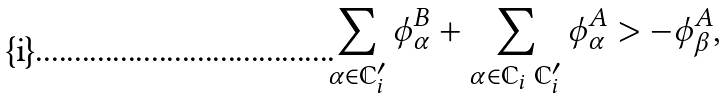Convert formula to latex. <formula><loc_0><loc_0><loc_500><loc_500>\sum _ { \alpha \in \mathbb { C } _ { i } ^ { \prime } } \phi ^ { B } _ { \alpha } + \sum _ { \alpha \in \mathbb { C } _ { i } \ \mathbb { C } _ { i } ^ { \prime } } \phi ^ { A } _ { \alpha } > - \phi ^ { A } _ { \beta } ,</formula> 